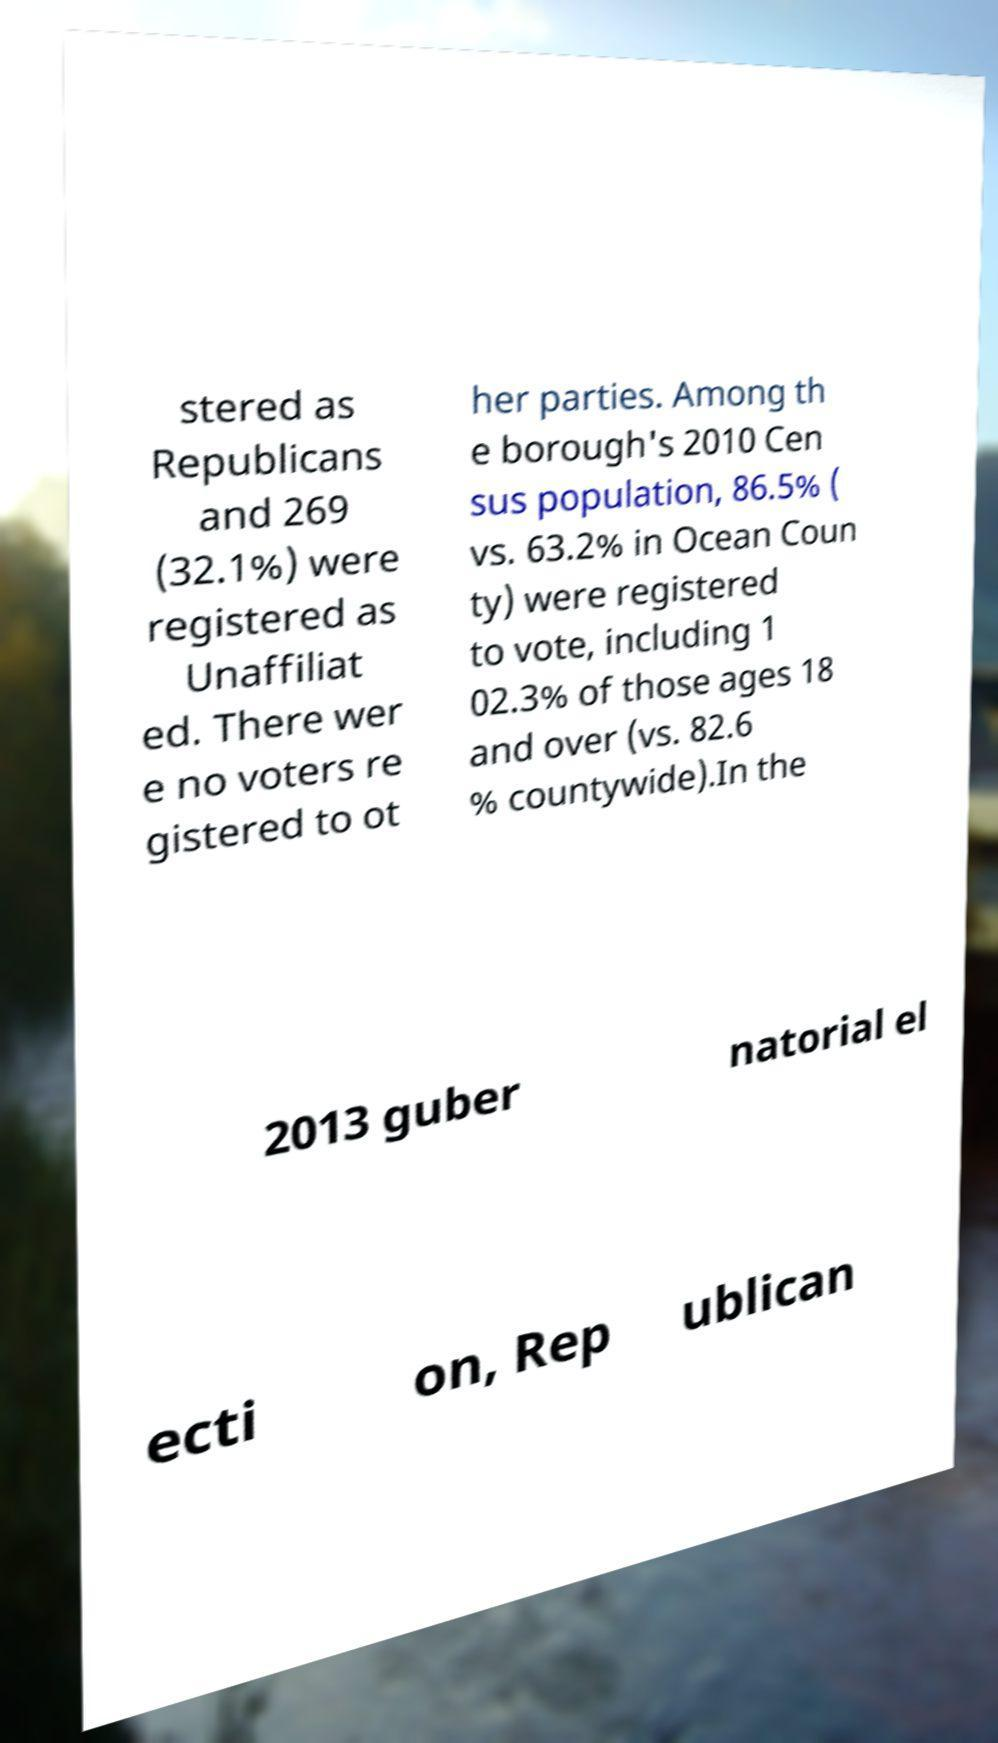What messages or text are displayed in this image? I need them in a readable, typed format. stered as Republicans and 269 (32.1%) were registered as Unaffiliat ed. There wer e no voters re gistered to ot her parties. Among th e borough's 2010 Cen sus population, 86.5% ( vs. 63.2% in Ocean Coun ty) were registered to vote, including 1 02.3% of those ages 18 and over (vs. 82.6 % countywide).In the 2013 guber natorial el ecti on, Rep ublican 